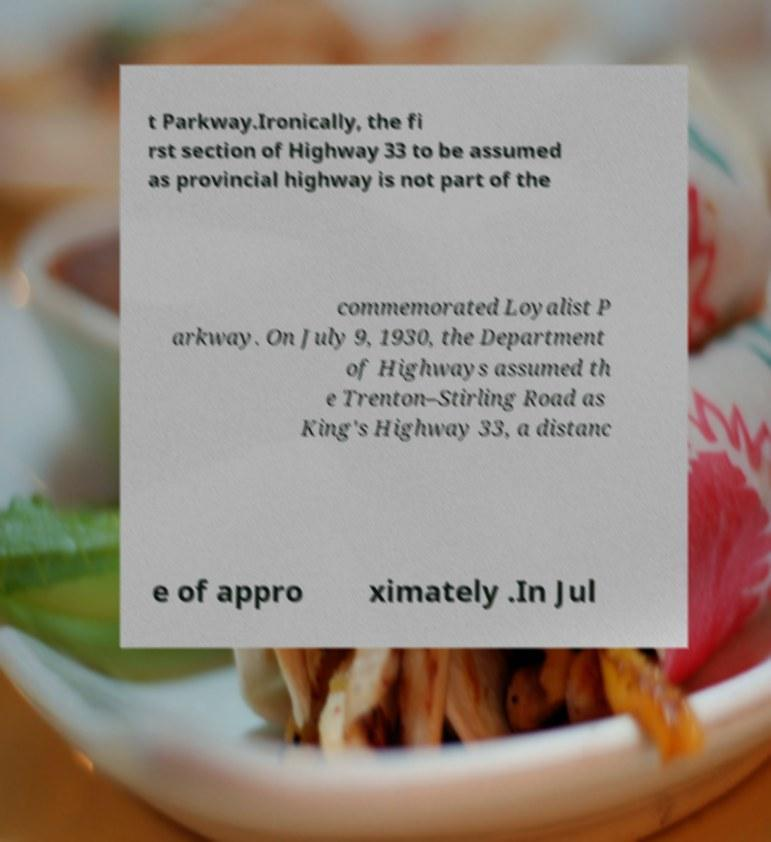What messages or text are displayed in this image? I need them in a readable, typed format. t Parkway.Ironically, the fi rst section of Highway 33 to be assumed as provincial highway is not part of the commemorated Loyalist P arkway. On July 9, 1930, the Department of Highways assumed th e Trenton–Stirling Road as King's Highway 33, a distanc e of appro ximately .In Jul 